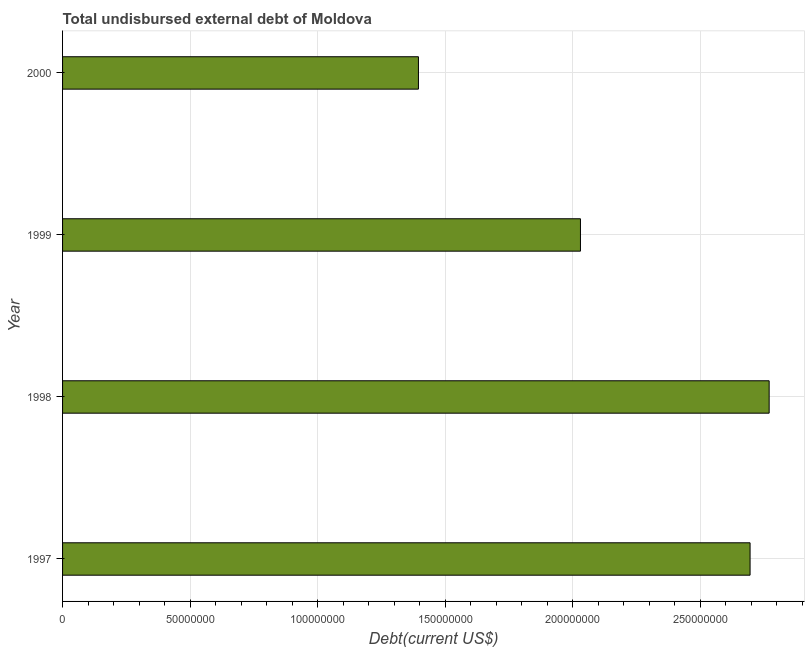Does the graph contain grids?
Offer a terse response. Yes. What is the title of the graph?
Give a very brief answer. Total undisbursed external debt of Moldova. What is the label or title of the X-axis?
Your answer should be very brief. Debt(current US$). What is the total debt in 2000?
Keep it short and to the point. 1.40e+08. Across all years, what is the maximum total debt?
Ensure brevity in your answer.  2.77e+08. Across all years, what is the minimum total debt?
Provide a succinct answer. 1.40e+08. In which year was the total debt maximum?
Offer a very short reply. 1998. In which year was the total debt minimum?
Provide a succinct answer. 2000. What is the sum of the total debt?
Provide a succinct answer. 8.89e+08. What is the difference between the total debt in 1999 and 2000?
Ensure brevity in your answer.  6.35e+07. What is the average total debt per year?
Make the answer very short. 2.22e+08. What is the median total debt?
Keep it short and to the point. 2.36e+08. In how many years, is the total debt greater than 100000000 US$?
Your answer should be compact. 4. What is the ratio of the total debt in 1997 to that in 1999?
Make the answer very short. 1.33. Is the total debt in 1998 less than that in 1999?
Your response must be concise. No. Is the difference between the total debt in 1999 and 2000 greater than the difference between any two years?
Your response must be concise. No. What is the difference between the highest and the second highest total debt?
Offer a very short reply. 7.48e+06. Is the sum of the total debt in 1997 and 2000 greater than the maximum total debt across all years?
Ensure brevity in your answer.  Yes. What is the difference between the highest and the lowest total debt?
Provide a short and direct response. 1.38e+08. Are all the bars in the graph horizontal?
Provide a succinct answer. Yes. How many years are there in the graph?
Your response must be concise. 4. What is the difference between two consecutive major ticks on the X-axis?
Make the answer very short. 5.00e+07. Are the values on the major ticks of X-axis written in scientific E-notation?
Make the answer very short. No. What is the Debt(current US$) in 1997?
Give a very brief answer. 2.70e+08. What is the Debt(current US$) in 1998?
Your answer should be compact. 2.77e+08. What is the Debt(current US$) of 1999?
Provide a short and direct response. 2.03e+08. What is the Debt(current US$) of 2000?
Keep it short and to the point. 1.40e+08. What is the difference between the Debt(current US$) in 1997 and 1998?
Your answer should be very brief. -7.48e+06. What is the difference between the Debt(current US$) in 1997 and 1999?
Keep it short and to the point. 6.65e+07. What is the difference between the Debt(current US$) in 1997 and 2000?
Give a very brief answer. 1.30e+08. What is the difference between the Debt(current US$) in 1998 and 1999?
Your response must be concise. 7.40e+07. What is the difference between the Debt(current US$) in 1998 and 2000?
Your response must be concise. 1.38e+08. What is the difference between the Debt(current US$) in 1999 and 2000?
Offer a very short reply. 6.35e+07. What is the ratio of the Debt(current US$) in 1997 to that in 1999?
Your answer should be compact. 1.33. What is the ratio of the Debt(current US$) in 1997 to that in 2000?
Give a very brief answer. 1.93. What is the ratio of the Debt(current US$) in 1998 to that in 1999?
Your response must be concise. 1.36. What is the ratio of the Debt(current US$) in 1998 to that in 2000?
Your response must be concise. 1.99. What is the ratio of the Debt(current US$) in 1999 to that in 2000?
Provide a short and direct response. 1.46. 